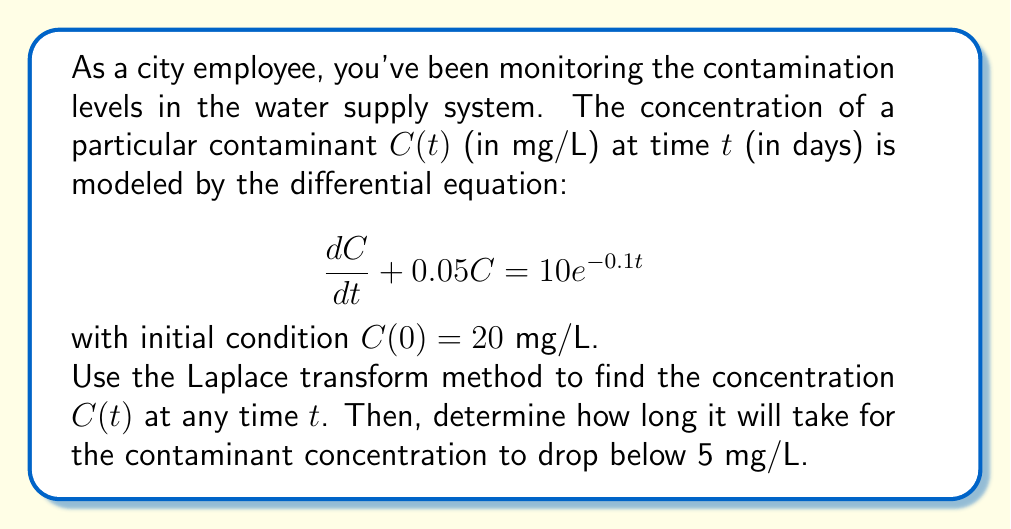Could you help me with this problem? Let's solve this problem step by step using the Laplace transform method:

1) Take the Laplace transform of both sides of the differential equation:
   $$\mathcal{L}\left\{\frac{dC}{dt} + 0.05C\right\} = \mathcal{L}\{10e^{-0.1t}\}$$

2) Using Laplace transform properties:
   $$s\mathcal{L}\{C\} - C(0) + 0.05\mathcal{L}\{C\} = \frac{10}{s+0.1}$$

3) Let $\mathcal{L}\{C\} = X(s)$. Substituting $C(0) = 20$:
   $$sX(s) - 20 + 0.05X(s) = \frac{10}{s+0.1}$$

4) Solve for $X(s)$:
   $$(s + 0.05)X(s) = 20 + \frac{10}{s+0.1}$$
   $$X(s) = \frac{20}{s + 0.05} + \frac{10}{(s+0.05)(s+0.1)}$$

5) Use partial fraction decomposition:
   $$X(s) = \frac{20}{s + 0.05} + \frac{A}{s+0.05} + \frac{B}{s+0.1}$$
   where $A = -\frac{200}{0.05} = -4000$ and $B = \frac{200}{0.05} = 4000$

6) Take the inverse Laplace transform:
   $$C(t) = 20e^{-0.05t} - 4000e^{-0.05t} + 4000e^{-0.1t}$$
   $$C(t) = 4000e^{-0.1t} - 3980e^{-0.05t}$$

7) To find when $C(t) < 5$, solve:
   $$4000e^{-0.1t} - 3980e^{-0.05t} = 5$$

   This can be solved numerically, yielding $t \approx 59.3$ days.
Answer: $C(t) = 4000e^{-0.1t} - 3980e^{-0.05t}$; 59.3 days 